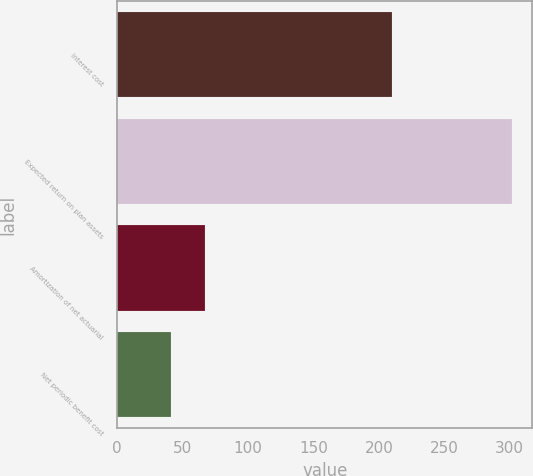Convert chart. <chart><loc_0><loc_0><loc_500><loc_500><bar_chart><fcel>Interest cost<fcel>Expected return on plan assets<fcel>Amortization of net actuarial<fcel>Net periodic benefit cost<nl><fcel>210<fcel>302<fcel>67.1<fcel>41<nl></chart> 